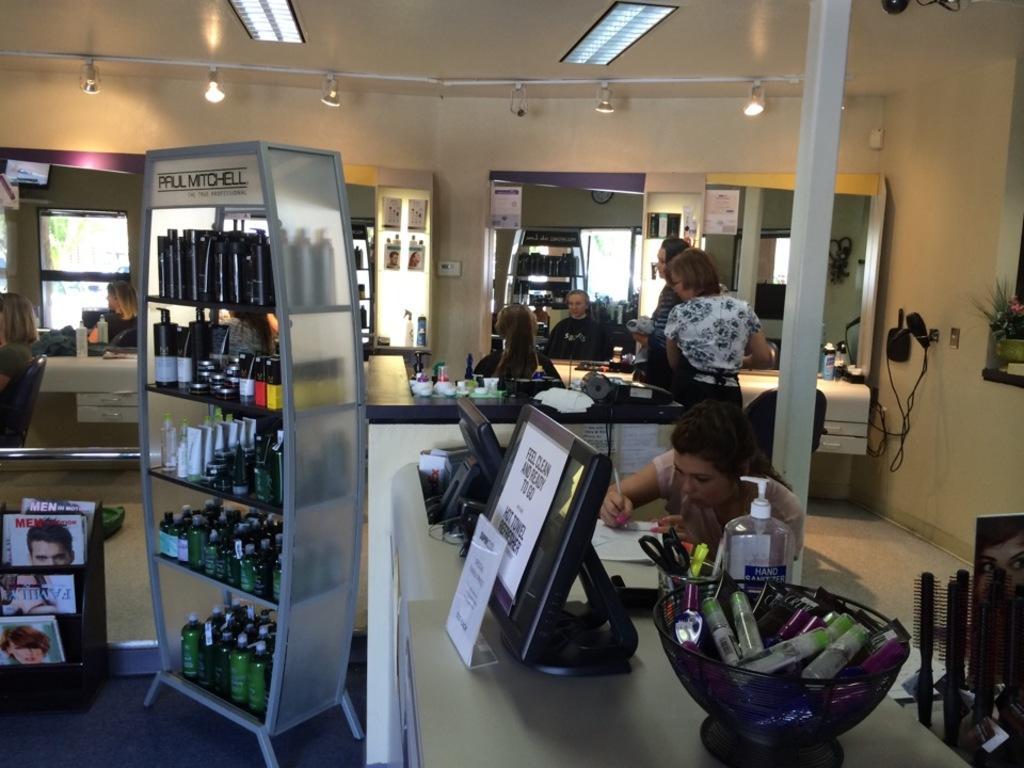Can you describe this image briefly? This is an inside view of a room. In the middle of the image there is a woman sitting in front of the mirror. Beside her two women are standing. At the bottom there is a table on which monitors, basket, bottles and some other objects are placed. Beside the table there is a woman holding a pen in the hand and writing on a paper which is placed on the table. In the bottom right-hand corner there are few combs. On the left side there is a rack which is filled with the bottles and tubes. It seems to be a parlor. On the right side there is a pole. In the background there are many bottles, bowls and other objects placed in the tracks and also I can see the windows to the wall. At the top of the image there are few lights. 